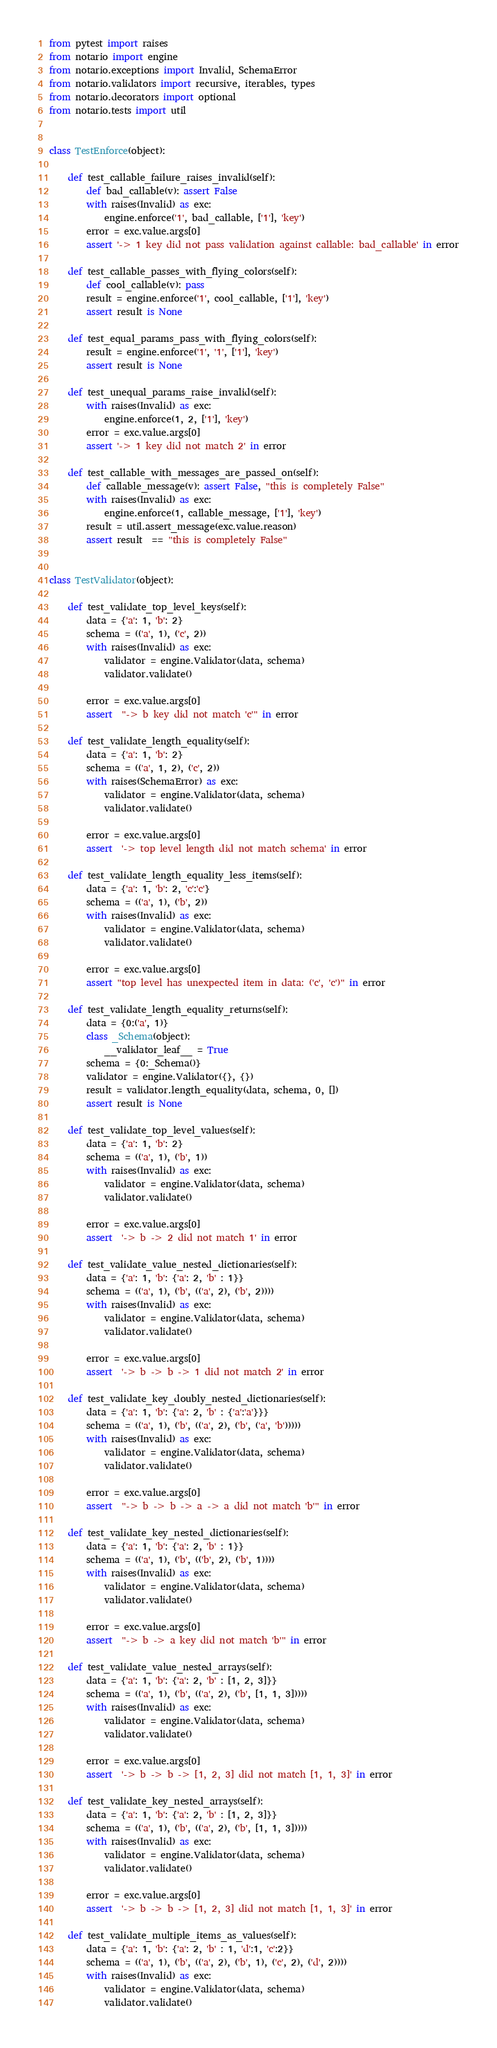<code> <loc_0><loc_0><loc_500><loc_500><_Python_>from pytest import raises
from notario import engine
from notario.exceptions import Invalid, SchemaError
from notario.validators import recursive, iterables, types
from notario.decorators import optional
from notario.tests import util


class TestEnforce(object):

    def test_callable_failure_raises_invalid(self):
        def bad_callable(v): assert False
        with raises(Invalid) as exc:
            engine.enforce('1', bad_callable, ['1'], 'key')
        error = exc.value.args[0]
        assert '-> 1 key did not pass validation against callable: bad_callable' in error

    def test_callable_passes_with_flying_colors(self):
        def cool_callable(v): pass
        result = engine.enforce('1', cool_callable, ['1'], 'key')
        assert result is None

    def test_equal_params_pass_with_flying_colors(self):
        result = engine.enforce('1', '1', ['1'], 'key')
        assert result is None

    def test_unequal_params_raise_invalid(self):
        with raises(Invalid) as exc:
            engine.enforce(1, 2, ['1'], 'key')
        error = exc.value.args[0]
        assert '-> 1 key did not match 2' in error

    def test_callable_with_messages_are_passed_on(self):
        def callable_message(v): assert False, "this is completely False"
        with raises(Invalid) as exc:
            engine.enforce(1, callable_message, ['1'], 'key')
        result = util.assert_message(exc.value.reason)
        assert result  == "this is completely False"


class TestValidator(object):

    def test_validate_top_level_keys(self):
        data = {'a': 1, 'b': 2}
        schema = (('a', 1), ('c', 2))
        with raises(Invalid) as exc:
            validator = engine.Validator(data, schema)
            validator.validate()

        error = exc.value.args[0]
        assert  "-> b key did not match 'c'" in error

    def test_validate_length_equality(self):
        data = {'a': 1, 'b': 2}
        schema = (('a', 1, 2), ('c', 2))
        with raises(SchemaError) as exc:
            validator = engine.Validator(data, schema)
            validator.validate()

        error = exc.value.args[0]
        assert  '-> top level length did not match schema' in error

    def test_validate_length_equality_less_items(self):
        data = {'a': 1, 'b': 2, 'c':'c'}
        schema = (('a', 1), ('b', 2))
        with raises(Invalid) as exc:
            validator = engine.Validator(data, schema)
            validator.validate()

        error = exc.value.args[0]
        assert "top level has unexpected item in data: ('c', 'c')" in error

    def test_validate_length_equality_returns(self):
        data = {0:('a', 1)}
        class _Schema(object):
            __validator_leaf__ = True
        schema = {0:_Schema()}
        validator = engine.Validator({}, {})
        result = validator.length_equality(data, schema, 0, [])
        assert result is None

    def test_validate_top_level_values(self):
        data = {'a': 1, 'b': 2}
        schema = (('a', 1), ('b', 1))
        with raises(Invalid) as exc:
            validator = engine.Validator(data, schema)
            validator.validate()

        error = exc.value.args[0]
        assert  '-> b -> 2 did not match 1' in error

    def test_validate_value_nested_dictionaries(self):
        data = {'a': 1, 'b': {'a': 2, 'b' : 1}}
        schema = (('a', 1), ('b', (('a', 2), ('b', 2))))
        with raises(Invalid) as exc:
            validator = engine.Validator(data, schema)
            validator.validate()

        error = exc.value.args[0]
        assert  '-> b -> b -> 1 did not match 2' in error

    def test_validate_key_doubly_nested_dictionaries(self):
        data = {'a': 1, 'b': {'a': 2, 'b' : {'a':'a'}}}
        schema = (('a', 1), ('b', (('a', 2), ('b', ('a', 'b')))))
        with raises(Invalid) as exc:
            validator = engine.Validator(data, schema)
            validator.validate()

        error = exc.value.args[0]
        assert  "-> b -> b -> a -> a did not match 'b'" in error

    def test_validate_key_nested_dictionaries(self):
        data = {'a': 1, 'b': {'a': 2, 'b' : 1}}
        schema = (('a', 1), ('b', (('b', 2), ('b', 1))))
        with raises(Invalid) as exc:
            validator = engine.Validator(data, schema)
            validator.validate()

        error = exc.value.args[0]
        assert  "-> b -> a key did not match 'b'" in error

    def test_validate_value_nested_arrays(self):
        data = {'a': 1, 'b': {'a': 2, 'b' : [1, 2, 3]}}
        schema = (('a', 1), ('b', (('a', 2), ('b', [1, 1, 3]))))
        with raises(Invalid) as exc:
            validator = engine.Validator(data, schema)
            validator.validate()

        error = exc.value.args[0]
        assert  '-> b -> b -> [1, 2, 3] did not match [1, 1, 3]' in error

    def test_validate_key_nested_arrays(self):
        data = {'a': 1, 'b': {'a': 2, 'b' : [1, 2, 3]}}
        schema = (('a', 1), ('b', (('a', 2), ('b', [1, 1, 3]))))
        with raises(Invalid) as exc:
            validator = engine.Validator(data, schema)
            validator.validate()

        error = exc.value.args[0]
        assert  '-> b -> b -> [1, 2, 3] did not match [1, 1, 3]' in error

    def test_validate_multiple_items_as_values(self):
        data = {'a': 1, 'b': {'a': 2, 'b' : 1, 'd':1, 'c':2}}
        schema = (('a', 1), ('b', (('a', 2), ('b', 1), ('c', 2), ('d', 2))))
        with raises(Invalid) as exc:
            validator = engine.Validator(data, schema)
            validator.validate()
</code> 